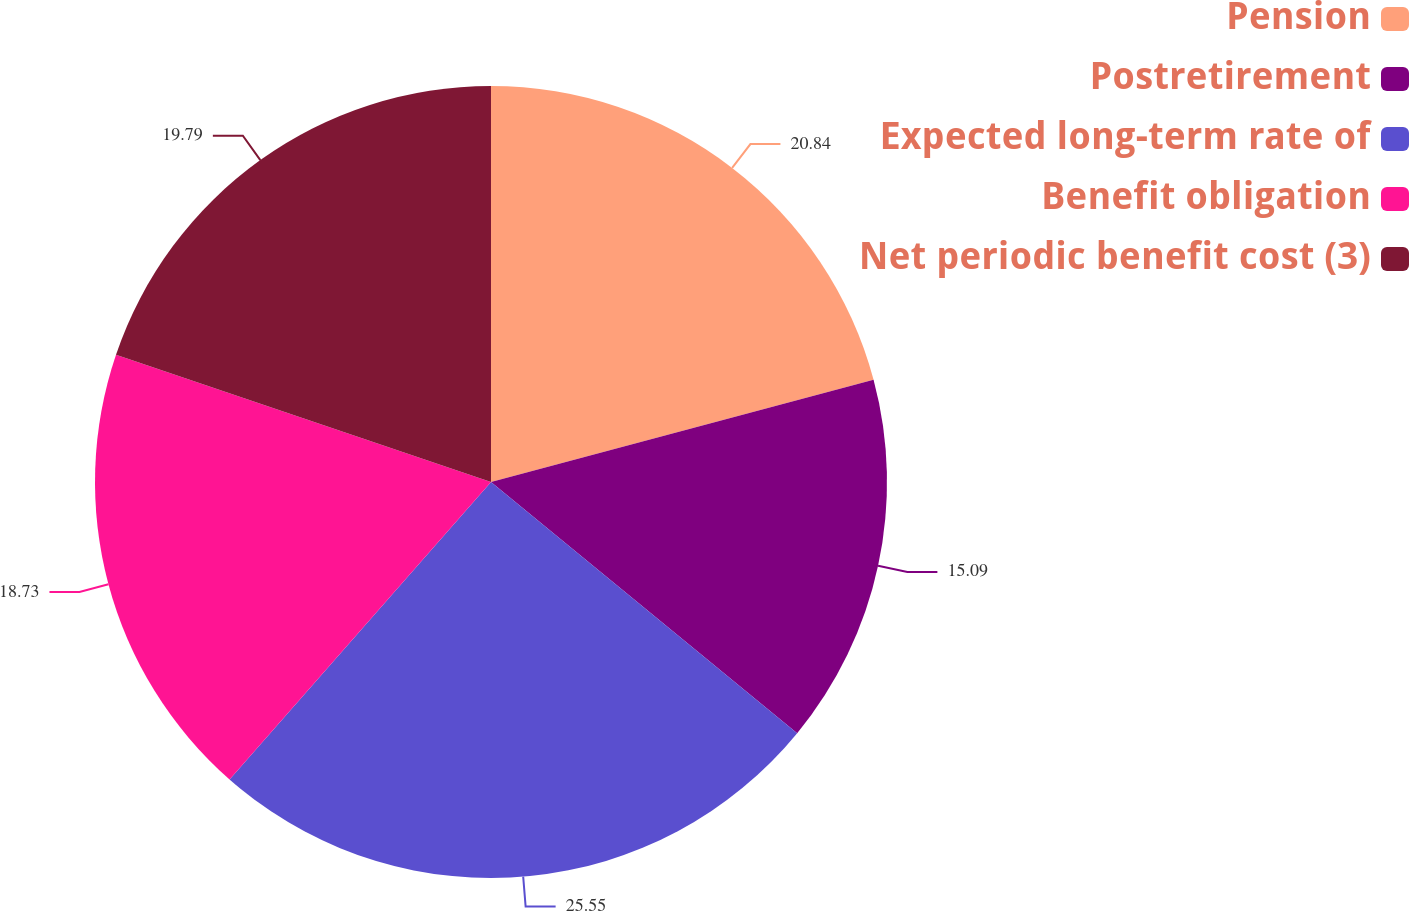<chart> <loc_0><loc_0><loc_500><loc_500><pie_chart><fcel>Pension<fcel>Postretirement<fcel>Expected long-term rate of<fcel>Benefit obligation<fcel>Net periodic benefit cost (3)<nl><fcel>20.84%<fcel>15.09%<fcel>25.54%<fcel>18.73%<fcel>19.79%<nl></chart> 